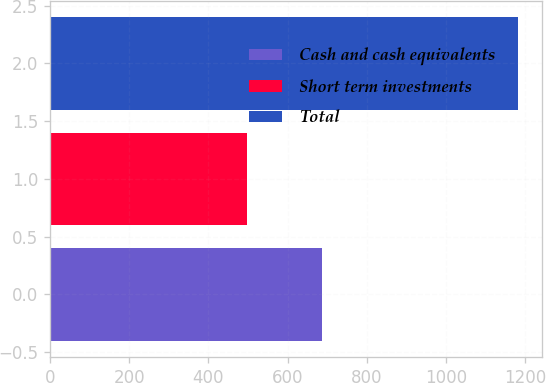Convert chart. <chart><loc_0><loc_0><loc_500><loc_500><bar_chart><fcel>Cash and cash equivalents<fcel>Short term investments<fcel>Total<nl><fcel>686<fcel>497<fcel>1183<nl></chart> 